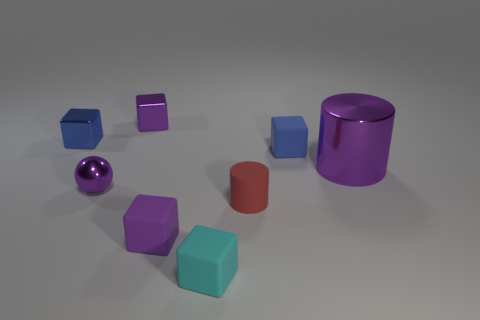Subtract all cyan blocks. How many blocks are left? 4 Subtract all small purple metallic cubes. How many cubes are left? 4 Subtract all red cubes. Subtract all yellow balls. How many cubes are left? 5 Add 1 tiny purple rubber things. How many objects exist? 9 Subtract all cubes. How many objects are left? 3 Add 3 big green cylinders. How many big green cylinders exist? 3 Subtract 1 red cylinders. How many objects are left? 7 Subtract all tiny purple balls. Subtract all red matte spheres. How many objects are left? 7 Add 1 small purple objects. How many small purple objects are left? 4 